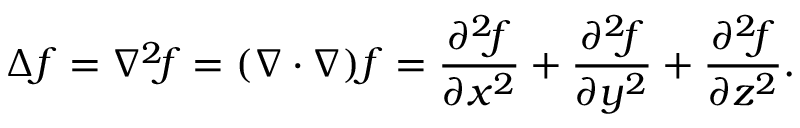<formula> <loc_0><loc_0><loc_500><loc_500>\Delta f = \nabla ^ { 2 } \, f = ( \nabla \cdot \nabla ) f = { \frac { \partial ^ { 2 } \, f } { \partial x ^ { 2 } } } + { \frac { \partial ^ { 2 } \, f } { \partial y ^ { 2 } } } + { \frac { \partial ^ { 2 } \, f } { \partial z ^ { 2 } } } .</formula> 